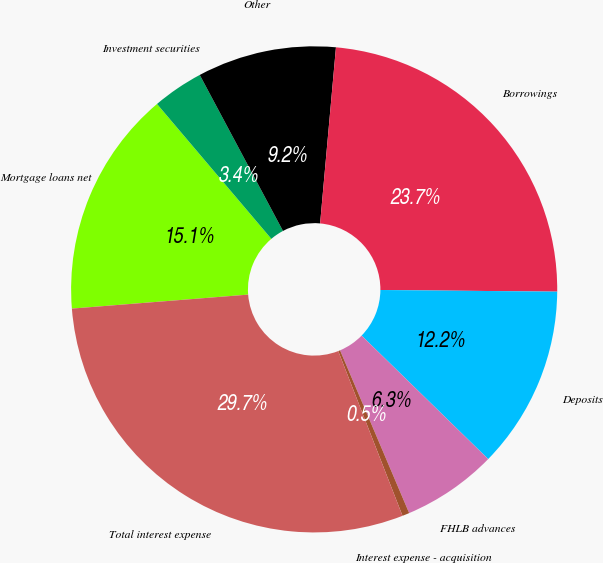<chart> <loc_0><loc_0><loc_500><loc_500><pie_chart><fcel>Mortgage loans net<fcel>Investment securities<fcel>Other<fcel>Borrowings<fcel>Deposits<fcel>FHLB advances<fcel>Interest expense - acquisition<fcel>Total interest expense<nl><fcel>15.07%<fcel>3.39%<fcel>9.23%<fcel>23.72%<fcel>12.15%<fcel>6.31%<fcel>0.47%<fcel>29.66%<nl></chart> 